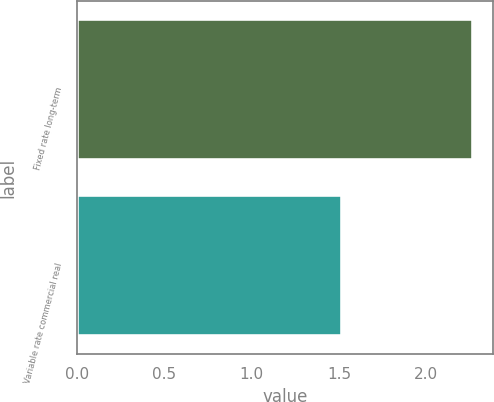<chart> <loc_0><loc_0><loc_500><loc_500><bar_chart><fcel>Fixed rate long-term<fcel>Variable rate commercial real<nl><fcel>2.27<fcel>1.52<nl></chart> 